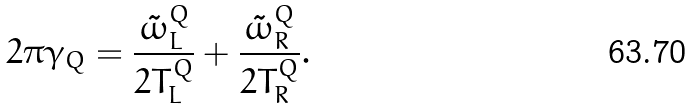Convert formula to latex. <formula><loc_0><loc_0><loc_500><loc_500>2 \pi \gamma _ { Q } = \frac { \tilde { \omega } ^ { Q } _ { L } } { 2 T ^ { Q } _ { L } } + \frac { \tilde { \omega } ^ { Q } _ { R } } { 2 T ^ { Q } _ { R } } .</formula> 